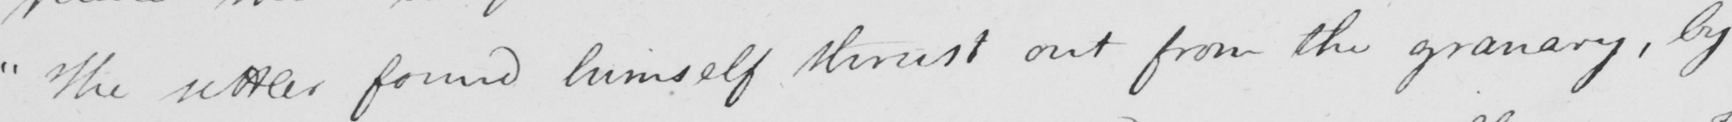Can you tell me what this handwritten text says? " The settler found himself thrust out from the granary , by 